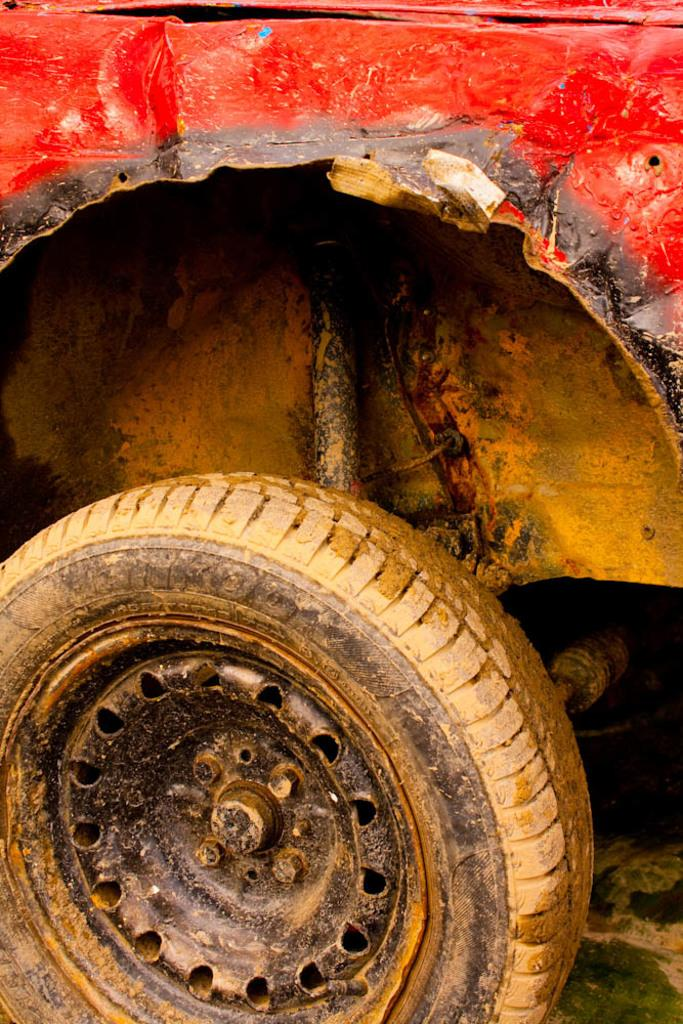What is the main subject of the image? The main subject of the image is a car. What part of the car is mentioned in the facts? There is a tire attached to the car. How is the tire positioned in relation to the car? The tire is placed on the ground. What type of kite is being flown by the train in the image? There is no kite or train present in the image; it features a car with a tire placed on the ground. How is the butter being used in the image? There is no butter present in the image. 